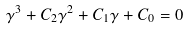<formula> <loc_0><loc_0><loc_500><loc_500>\gamma ^ { 3 } + C _ { 2 } \gamma ^ { 2 } + C _ { 1 } \gamma + C _ { 0 } = 0</formula> 